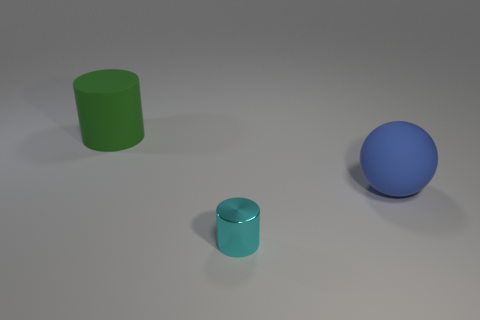Is there any other thing that has the same material as the small cyan cylinder?
Ensure brevity in your answer.  No. There is a rubber thing that is on the right side of the rubber cylinder; does it have the same size as the cylinder on the left side of the small thing?
Your answer should be compact. Yes. Are there any shiny objects of the same shape as the green matte object?
Your answer should be very brief. Yes. Is the number of cyan cylinders to the right of the cyan metallic cylinder less than the number of big cyan metallic blocks?
Your answer should be compact. No. Is the shape of the large blue matte thing the same as the small metal thing?
Give a very brief answer. No. There is a thing that is in front of the large blue sphere; what size is it?
Offer a terse response. Small. What size is the cylinder that is made of the same material as the sphere?
Provide a short and direct response. Large. Is the number of large things less than the number of objects?
Make the answer very short. Yes. There is a sphere that is the same size as the green rubber thing; what is it made of?
Your answer should be compact. Rubber. Are there more large purple rubber cylinders than large blue objects?
Your response must be concise. No. 